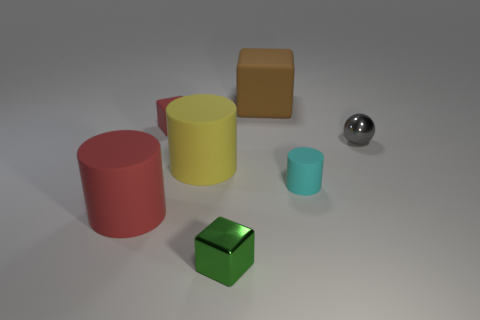The large matte thing that is the same color as the tiny matte cube is what shape? cylinder 